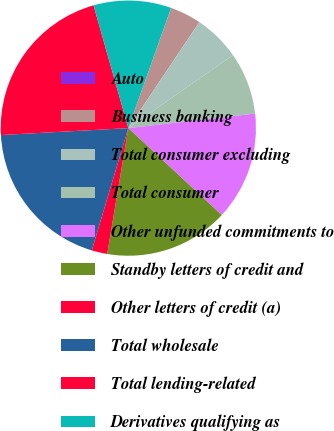<chart> <loc_0><loc_0><loc_500><loc_500><pie_chart><fcel>Auto<fcel>Business banking<fcel>Total consumer excluding<fcel>Total consumer<fcel>Other unfunded commitments to<fcel>Standby letters of credit and<fcel>Other letters of credit (a)<fcel>Total wholesale<fcel>Total lending-related<fcel>Derivatives qualifying as<nl><fcel>0.02%<fcel>3.94%<fcel>5.91%<fcel>7.87%<fcel>13.75%<fcel>15.72%<fcel>1.98%<fcel>19.51%<fcel>21.47%<fcel>9.83%<nl></chart> 